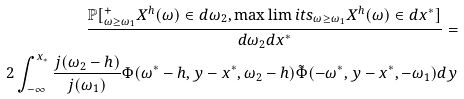Convert formula to latex. <formula><loc_0><loc_0><loc_500><loc_500>\frac { \mathbb { P } [ ^ { + } _ { \omega \geq \omega _ { 1 } } X ^ { h } ( \omega ) \in d \omega _ { 2 } , \max \lim i t s _ { \omega \geq \omega _ { 1 } } X ^ { h } ( \omega ) \in d x ^ { * } ] } { d \omega _ { 2 } d x ^ { * } } = \\ 2 \int _ { - \infty } ^ { x _ { * } } \frac { j ( \omega _ { 2 } - h ) } { j ( \omega _ { 1 } ) } \Phi ( \omega ^ { * } - h , y - x ^ { * } , \omega _ { 2 } - h ) \tilde { \Phi } ( - \omega ^ { * } , y - x ^ { * } , - \omega _ { 1 } ) d y</formula> 